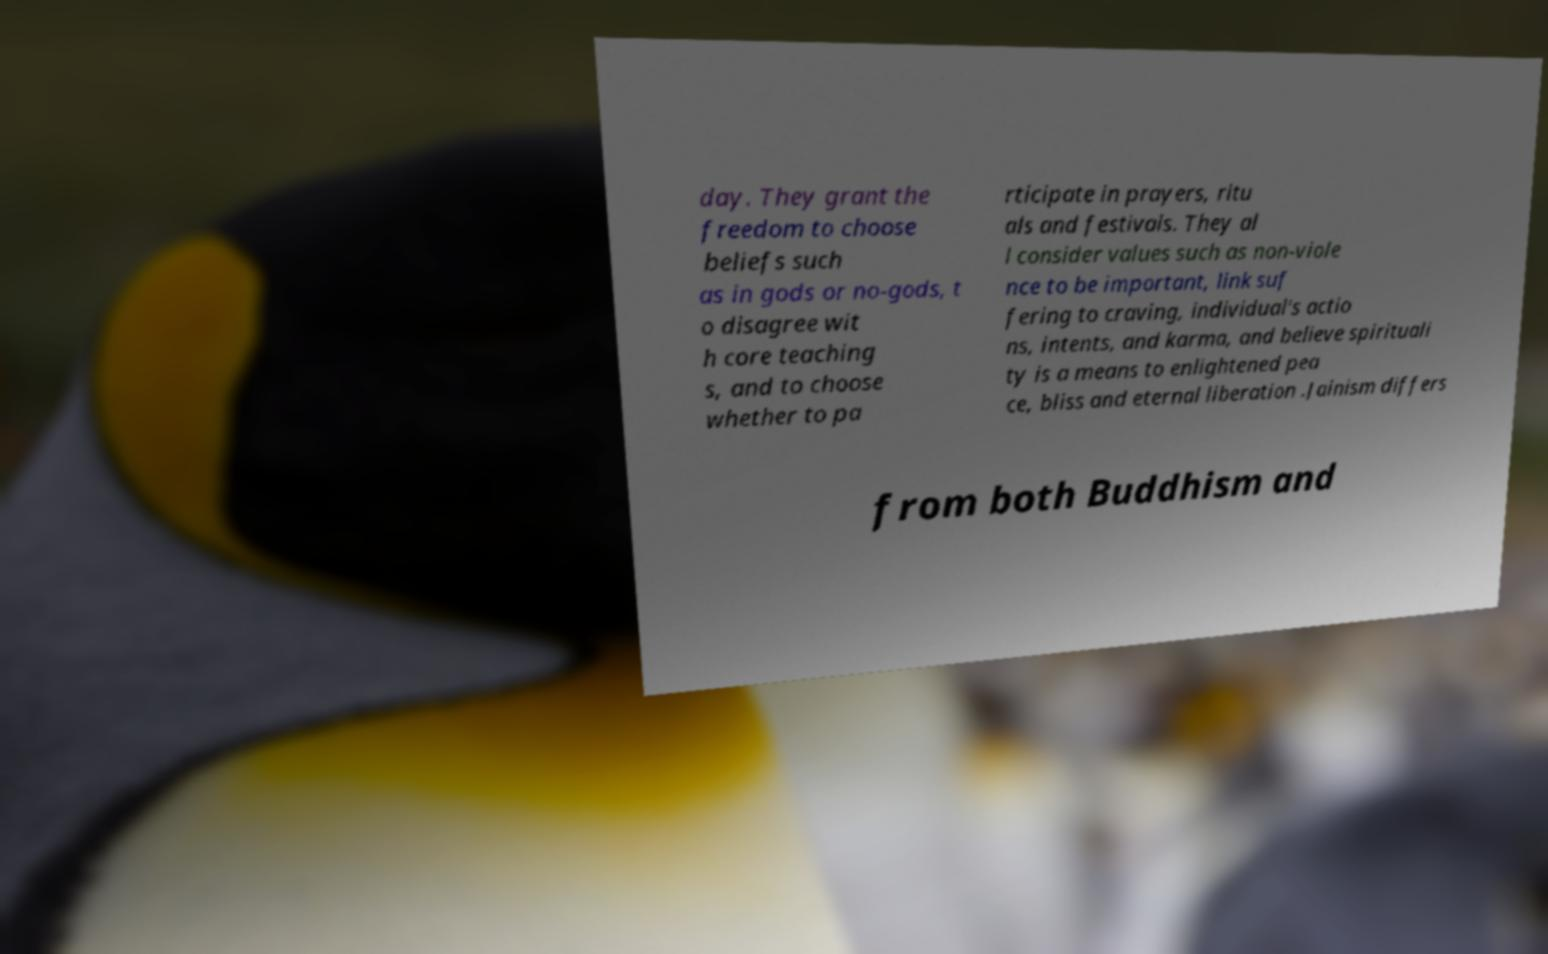I need the written content from this picture converted into text. Can you do that? day. They grant the freedom to choose beliefs such as in gods or no-gods, t o disagree wit h core teaching s, and to choose whether to pa rticipate in prayers, ritu als and festivals. They al l consider values such as non-viole nce to be important, link suf fering to craving, individual's actio ns, intents, and karma, and believe spirituali ty is a means to enlightened pea ce, bliss and eternal liberation .Jainism differs from both Buddhism and 